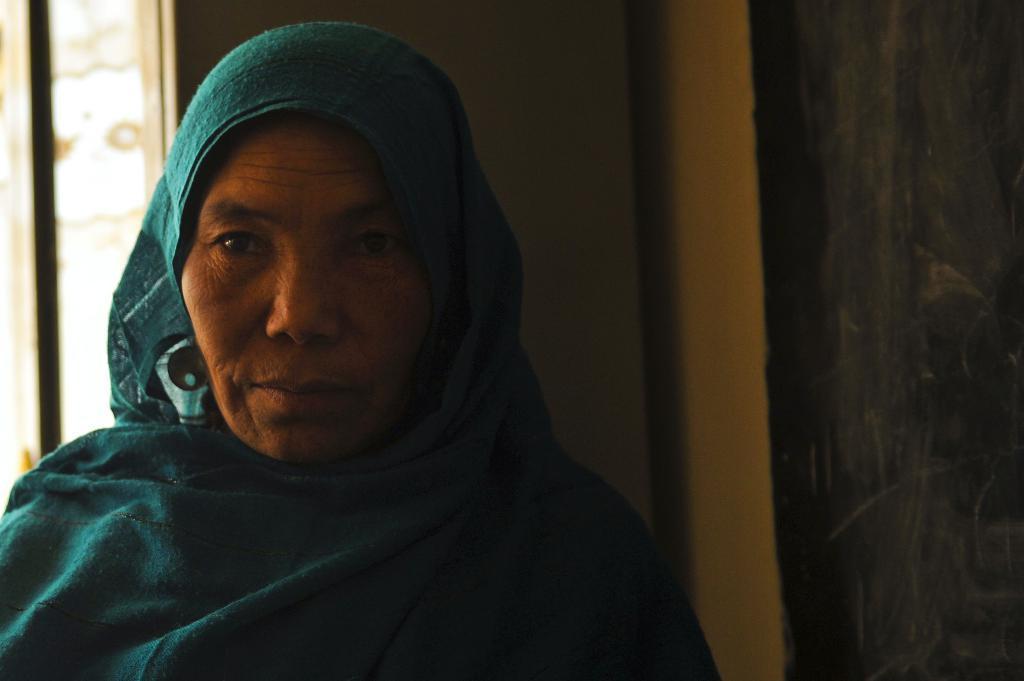How would you summarize this image in a sentence or two? In the image there is an old woman with a sea green color cloth over her head standing beside a wall and behind her it seems to be a window on the wall. 